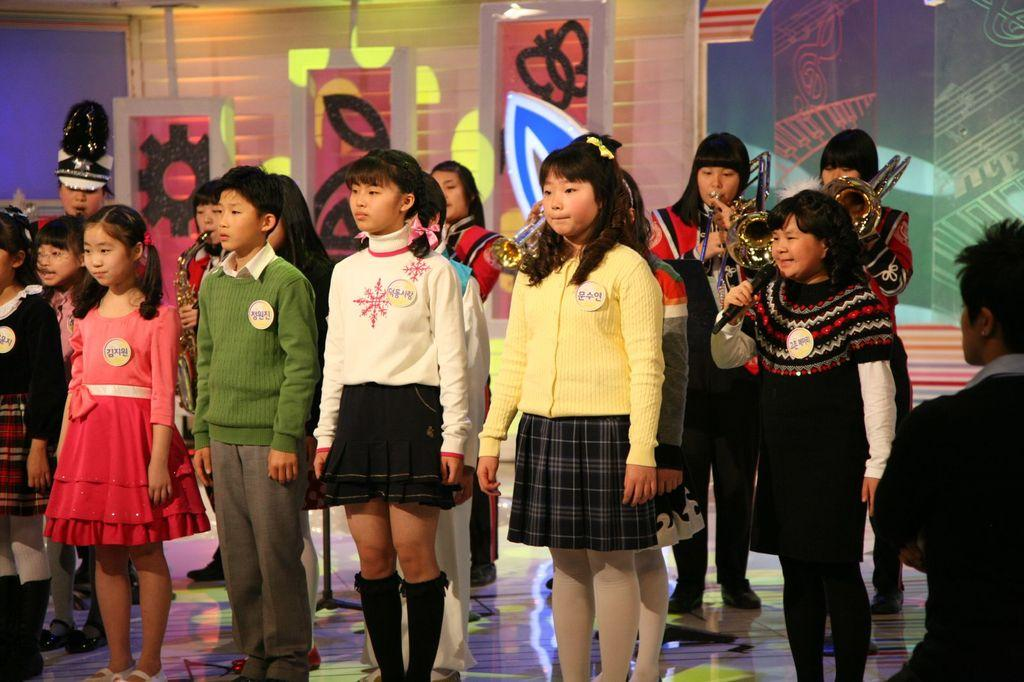How many people are in the image? There is a group of people in the image. What are some of the people doing in the image? Some people are holding microphones, and some are playing musical instruments. What can be seen in the background of the image? There are arts visible in the background of the image. Where is the scarecrow located in the image? There is no scarecrow present in the image. What type of cat can be seen playing with a quince in the image? There is no cat or quince present in the image. 